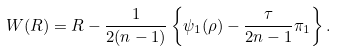<formula> <loc_0><loc_0><loc_500><loc_500>W ( R ) = R - \frac { 1 } { 2 ( n - 1 ) } \left \{ \psi _ { 1 } ( \rho ) - \frac { \tau } { 2 n - 1 } \pi _ { 1 } \right \} .</formula> 